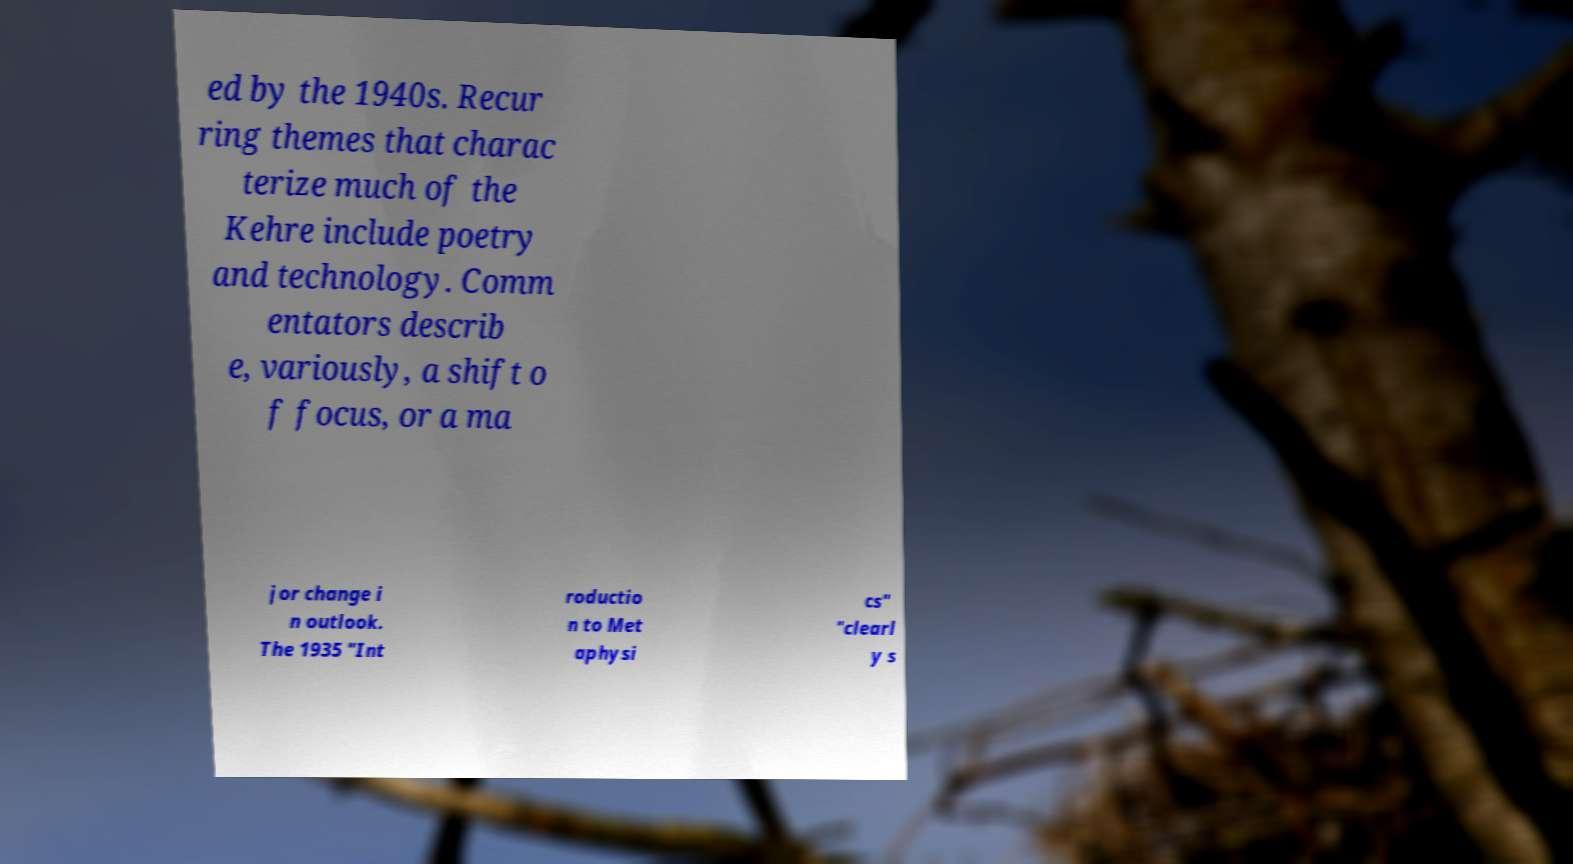Please identify and transcribe the text found in this image. ed by the 1940s. Recur ring themes that charac terize much of the Kehre include poetry and technology. Comm entators describ e, variously, a shift o f focus, or a ma jor change i n outlook. The 1935 "Int roductio n to Met aphysi cs" "clearl y s 